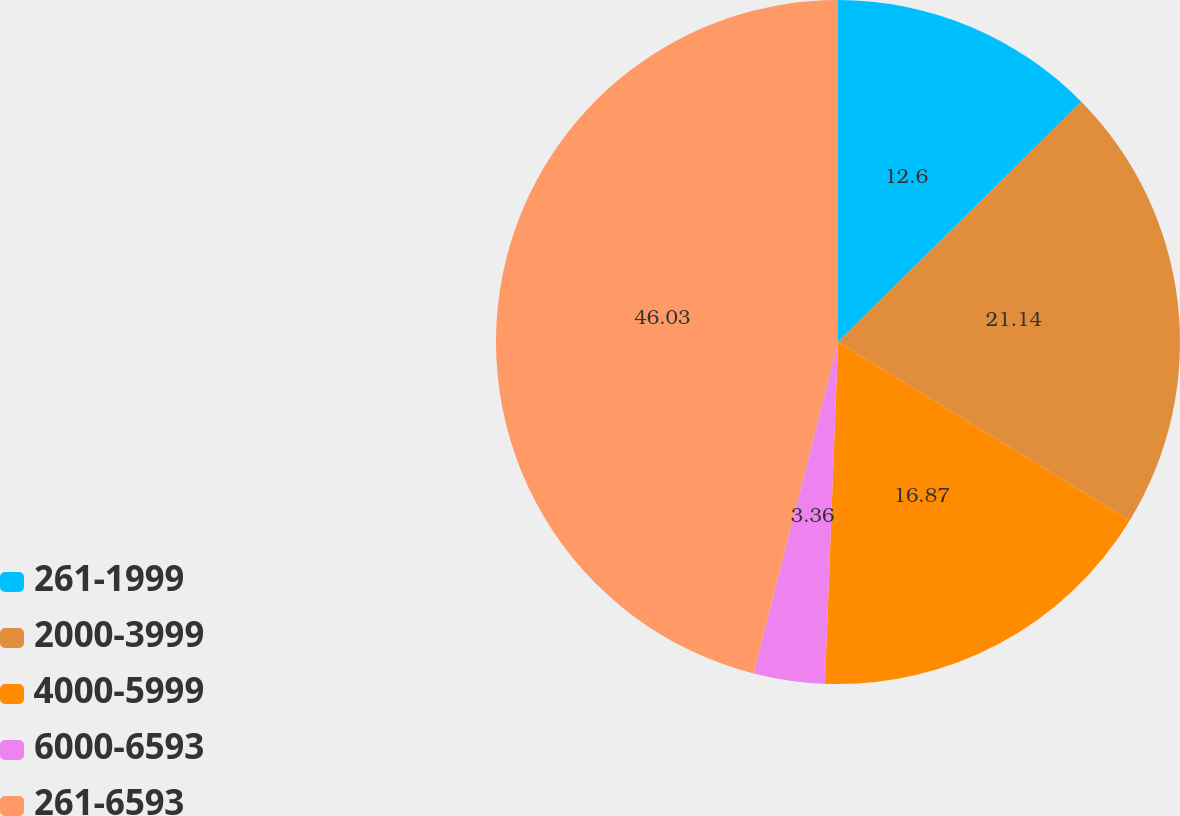Convert chart to OTSL. <chart><loc_0><loc_0><loc_500><loc_500><pie_chart><fcel>261-1999<fcel>2000-3999<fcel>4000-5999<fcel>6000-6593<fcel>261-6593<nl><fcel>12.6%<fcel>21.14%<fcel>16.87%<fcel>3.36%<fcel>46.03%<nl></chart> 